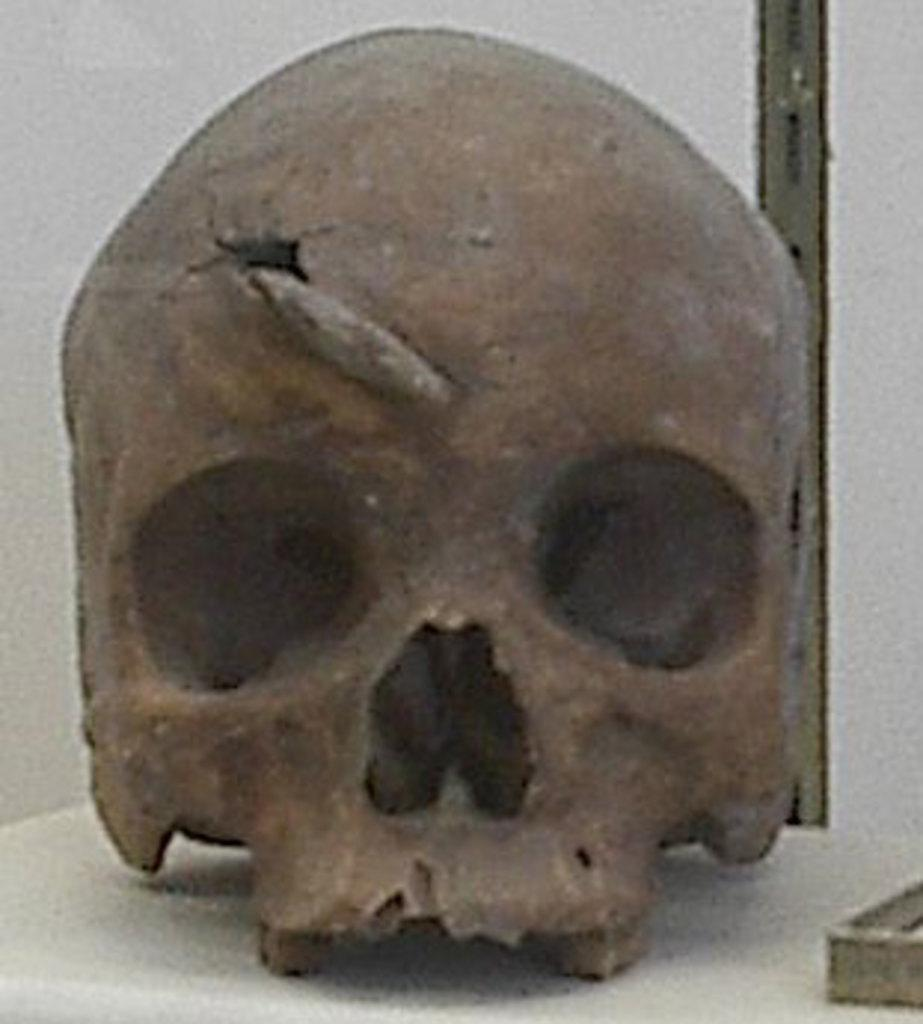What is the main subject of the image? The main subject of the image is a skull. What color is the skull? The skull is brown in color. What is the skull resting on in the image? The skull is on a white surface. What color is the background of the image? The background of the image is white. How many veins can be seen branching out from the skull in the image? There are no veins visible in the image, as it only features a brown skull on a white surface with a white background. 